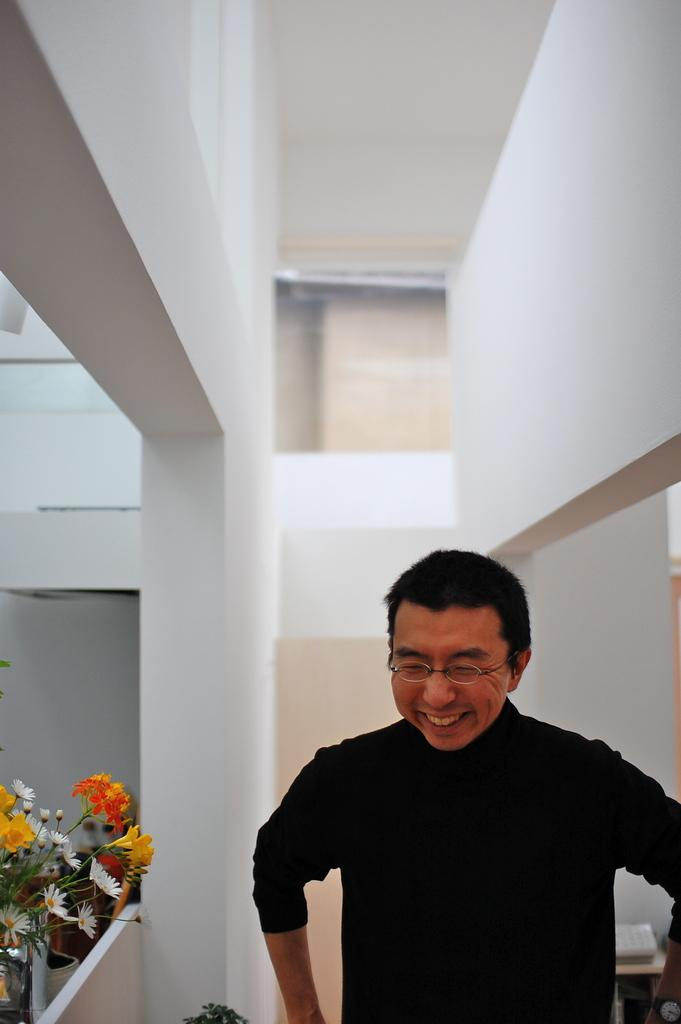What is the main subject in the image? There is a man standing in the image. What else can be seen in the image besides the man? There is a plant and a wall in the image. How many apples are on the wall in the image? There are no apples present in the image; it features a man, a plant, and a wall. What type of fold can be seen in the man's clothing in the image? There is no fold visible in the man's clothing in the image. 